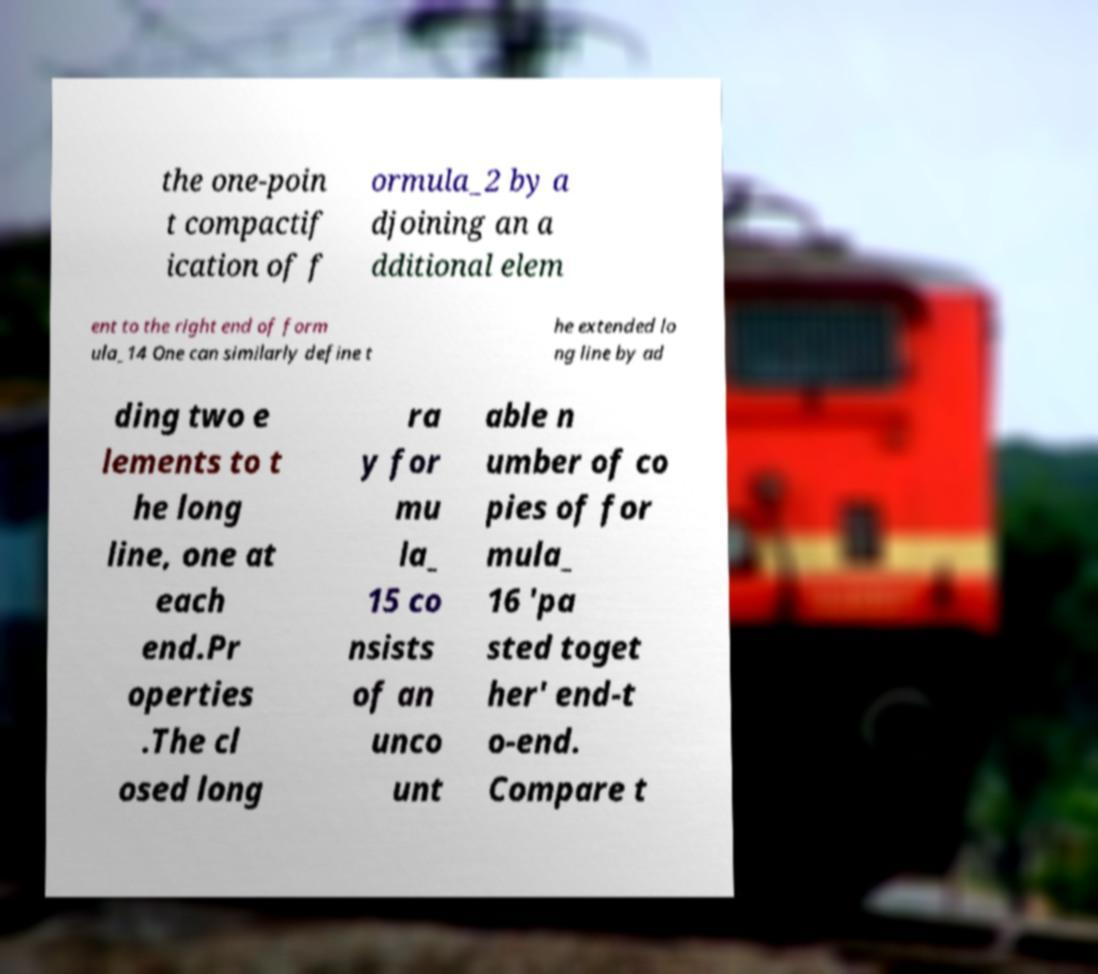Could you extract and type out the text from this image? the one-poin t compactif ication of f ormula_2 by a djoining an a dditional elem ent to the right end of form ula_14 One can similarly define t he extended lo ng line by ad ding two e lements to t he long line, one at each end.Pr operties .The cl osed long ra y for mu la_ 15 co nsists of an unco unt able n umber of co pies of for mula_ 16 'pa sted toget her' end-t o-end. Compare t 